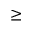Convert formula to latex. <formula><loc_0><loc_0><loc_500><loc_500>\geq</formula> 